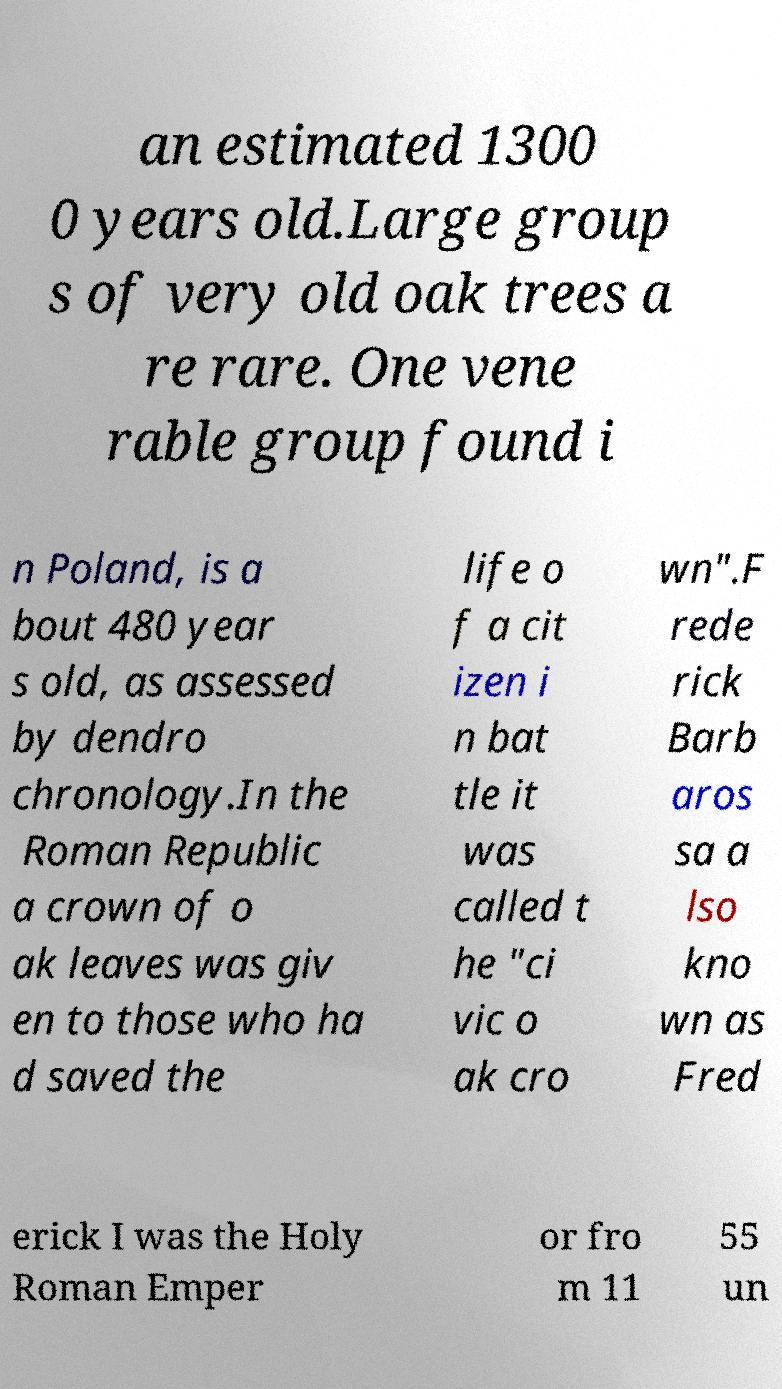Can you accurately transcribe the text from the provided image for me? an estimated 1300 0 years old.Large group s of very old oak trees a re rare. One vene rable group found i n Poland, is a bout 480 year s old, as assessed by dendro chronology.In the Roman Republic a crown of o ak leaves was giv en to those who ha d saved the life o f a cit izen i n bat tle it was called t he "ci vic o ak cro wn".F rede rick Barb aros sa a lso kno wn as Fred erick I was the Holy Roman Emper or fro m 11 55 un 